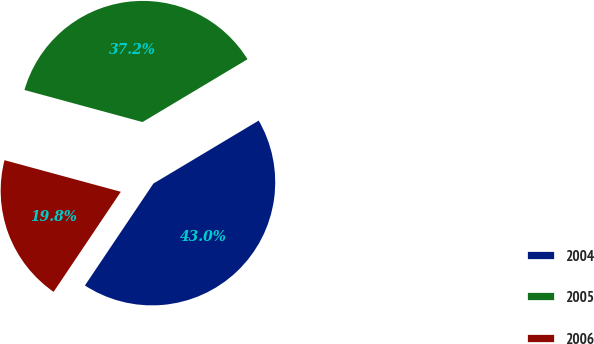Convert chart to OTSL. <chart><loc_0><loc_0><loc_500><loc_500><pie_chart><fcel>2004<fcel>2005<fcel>2006<nl><fcel>43.0%<fcel>37.2%<fcel>19.81%<nl></chart> 